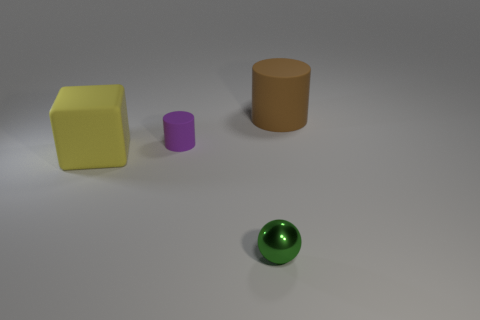There is a small green metallic object; what number of large blocks are to the right of it?
Provide a succinct answer. 0. Are there fewer big cylinders than large matte things?
Provide a succinct answer. Yes. There is a object that is on the right side of the tiny matte cylinder and on the left side of the brown matte object; what is its size?
Make the answer very short. Small. There is a matte cylinder that is in front of the brown cylinder; is its color the same as the sphere?
Provide a succinct answer. No. Is the number of green metal spheres behind the large rubber cylinder less than the number of blocks?
Your answer should be very brief. Yes. What is the shape of the big thing that is the same material as the cube?
Your answer should be compact. Cylinder. Are the cube and the green object made of the same material?
Keep it short and to the point. No. Is the number of cylinders that are in front of the brown matte cylinder less than the number of big objects behind the big yellow matte cube?
Your answer should be compact. No. How many tiny rubber cylinders are in front of the big yellow matte cube that is in front of the big brown thing right of the large yellow matte block?
Offer a very short reply. 0. Does the big cube have the same color as the ball?
Make the answer very short. No. 